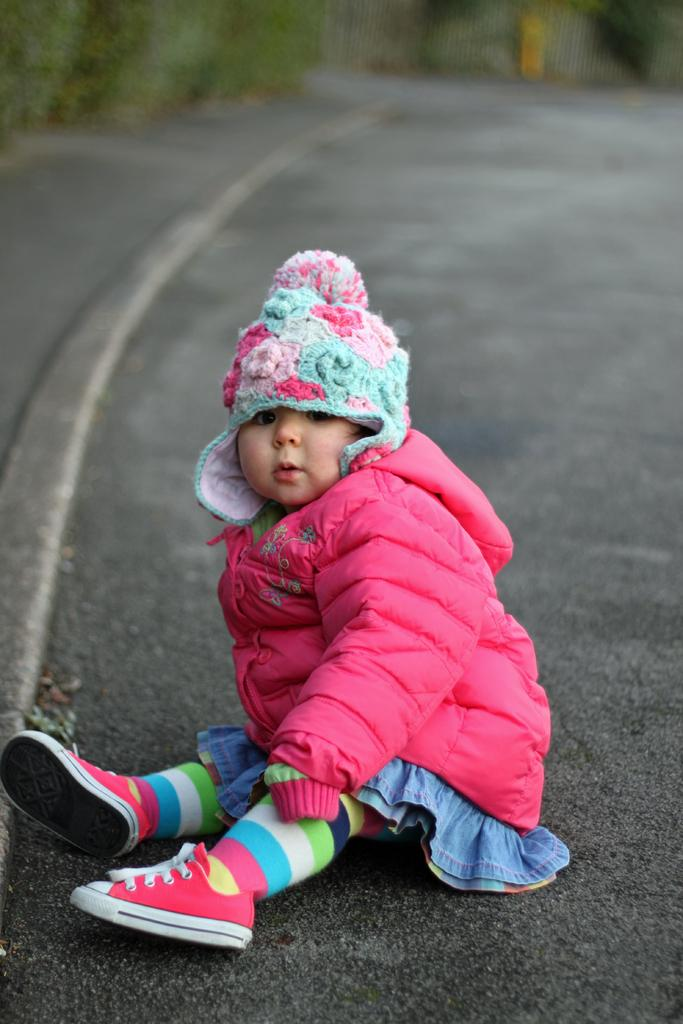Who is the main subject in the image? There is a girl in the image. What is the girl wearing? The girl is wearing a jacket. Where is the girl sitting in the image? The girl is sitting on the road. What type of meat is the girl holding in the image? There is no meat present in the image; the girl is not holding any food items. 